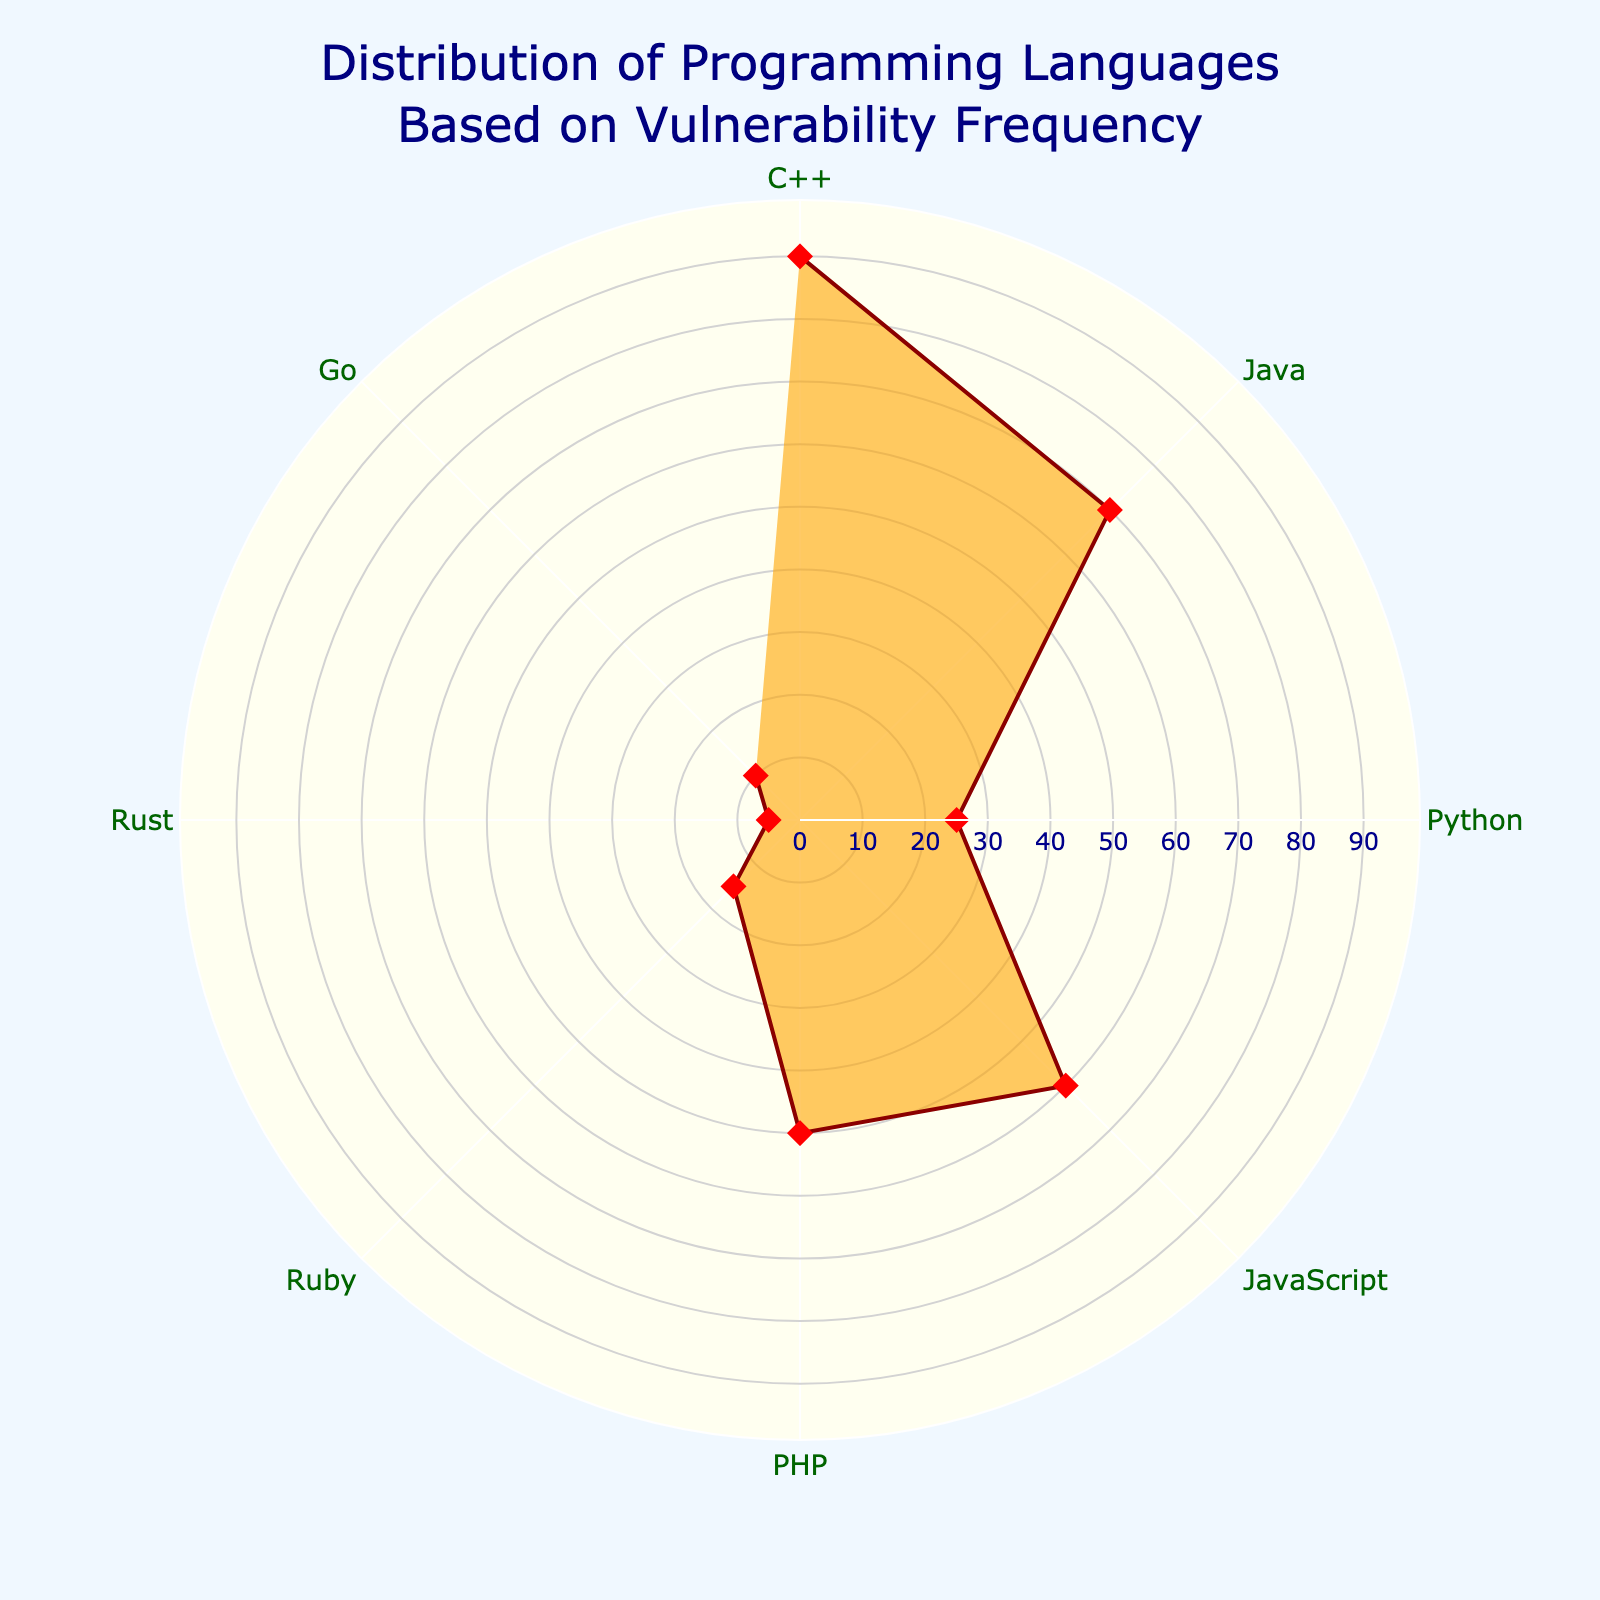what is the title of the chart? The title of the chart is displayed at the top center, showing the main topic of the chart.
Answer: Distribution of Programming Languages Based on Vulnerability Frequency Which programming language has the highest number of vulnerabilities? By looking at the radial axis, you can see that C++ extends the farthest, indicating it has the highest number of vulnerabilities.
Answer: C++ How many vulnerabilities does Python have? You can determine Python's number of vulnerabilities by locating the Python label and checking how far it extends on the radial axis. Python extends to 25 vulnerabilities.
Answer: 25 What is the difference in the number of vulnerabilities between JavaScript and PHP? Locate the JavaScript and PHP labels and their corresponding values on the radial axis (JavaScript: 60, PHP: 50). Subtract the smaller value from the larger one (60 - 50).
Answer: 10 Which three programming languages have the lowest number of vulnerabilities? Identify the programming languages with the shortest extensions on the radial axis. Rust, Ruby, and Go are the shortest, indicating they have the lowest number of vulnerabilities.
Answer: Rust, Ruby, Go What color is used to fill the area inside the plot? The color filling the area inside the plot is visually identifiable.
Answer: Orange Which language has twice as many vulnerabilities as Ruby? Locate Ruby's vulnerabilities (15) and find the programming language with approximately twice that amount. Go (10) is close but not exact; JavaScript (60) has the opposite of twice, therefore PHP with 50 fits about twice 15's multiple.
Answer: PHP What is the average number of vulnerabilities across all programming languages? Sum up the number of vulnerabilities for each programming language (90+70+25+60+50+15+5+10 = 325). Divide by the number of languages (8).
Answer: 40.625 What is the median number of vulnerabilities in the chart? List the numbers in ascending order (5, 10, 15, 25, 50, 60, 70, 90). The median is the middle value in a set of ordered values. Since there are 8 values in this case, average the 4th and 5th values ((25+50)/2).
Answer: 37.5 What shape and color is used for the data markers in the plot? Observe the markers used for each data point in the plot.
Answer: Diamond, Red 